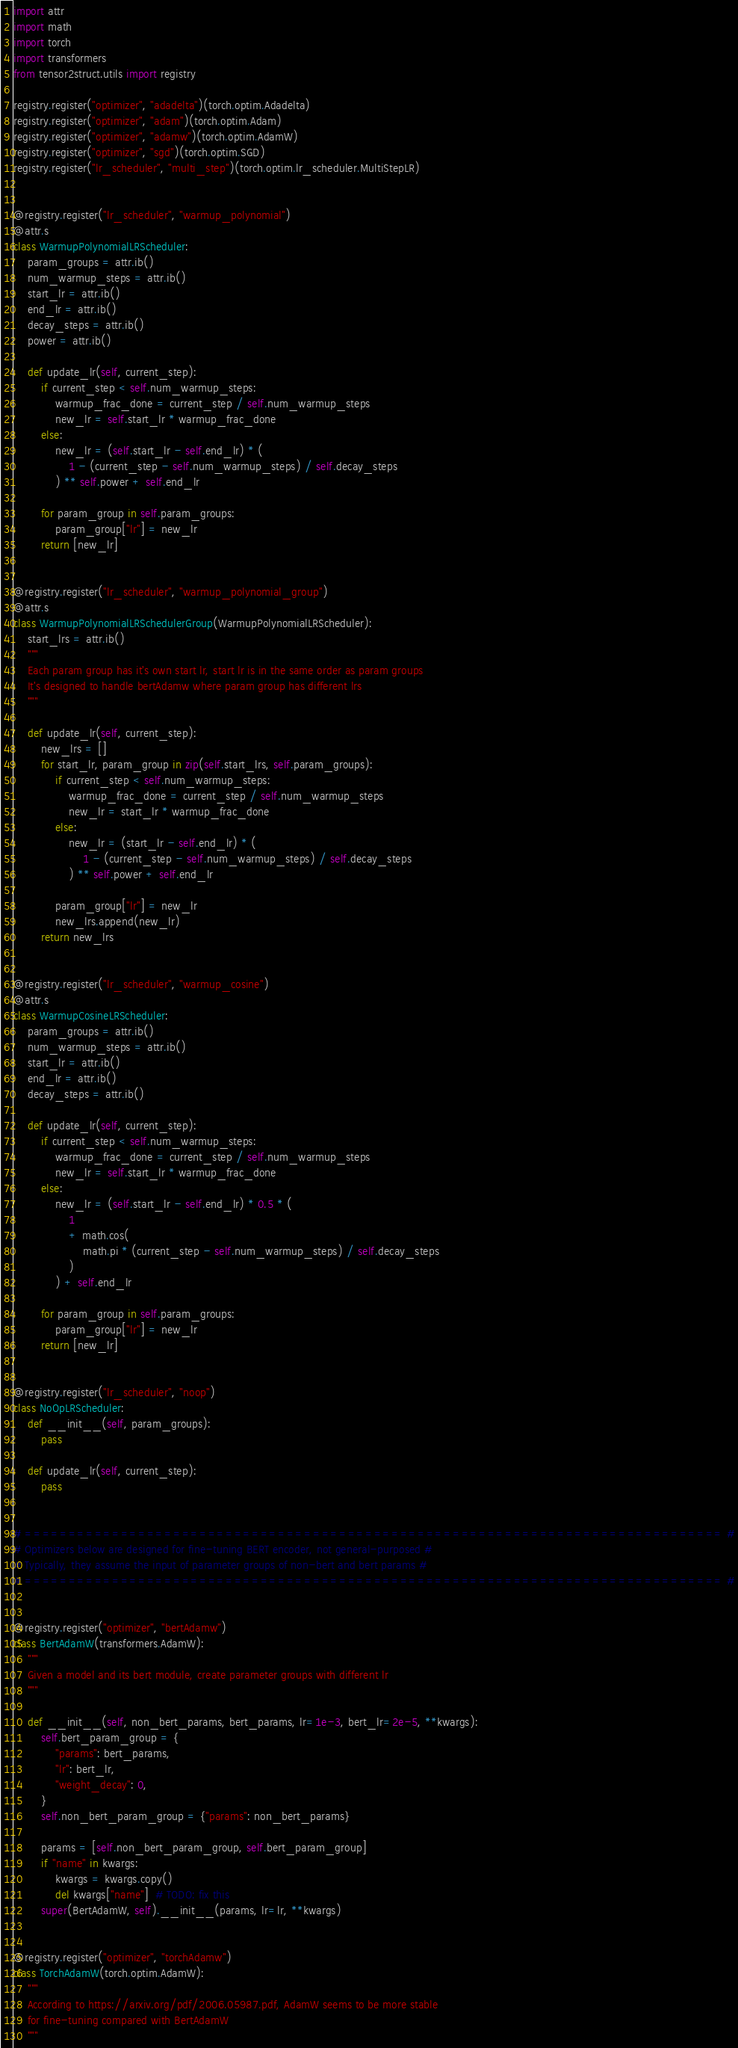<code> <loc_0><loc_0><loc_500><loc_500><_Python_>import attr
import math
import torch
import transformers
from tensor2struct.utils import registry

registry.register("optimizer", "adadelta")(torch.optim.Adadelta)
registry.register("optimizer", "adam")(torch.optim.Adam)
registry.register("optimizer", "adamw")(torch.optim.AdamW)
registry.register("optimizer", "sgd")(torch.optim.SGD)
registry.register("lr_scheduler", "multi_step")(torch.optim.lr_scheduler.MultiStepLR)


@registry.register("lr_scheduler", "warmup_polynomial")
@attr.s
class WarmupPolynomialLRScheduler:
    param_groups = attr.ib()
    num_warmup_steps = attr.ib()
    start_lr = attr.ib()
    end_lr = attr.ib()
    decay_steps = attr.ib()
    power = attr.ib()

    def update_lr(self, current_step):
        if current_step < self.num_warmup_steps:
            warmup_frac_done = current_step / self.num_warmup_steps
            new_lr = self.start_lr * warmup_frac_done
        else:
            new_lr = (self.start_lr - self.end_lr) * (
                1 - (current_step - self.num_warmup_steps) / self.decay_steps
            ) ** self.power + self.end_lr

        for param_group in self.param_groups:
            param_group["lr"] = new_lr
        return [new_lr]


@registry.register("lr_scheduler", "warmup_polynomial_group")
@attr.s
class WarmupPolynomialLRSchedulerGroup(WarmupPolynomialLRScheduler):
    start_lrs = attr.ib()
    """
    Each param group has it's own start lr, start lr is in the same order as param groups
    It's designed to handle bertAdamw where param group has different lrs
    """

    def update_lr(self, current_step):
        new_lrs = []
        for start_lr, param_group in zip(self.start_lrs, self.param_groups):
            if current_step < self.num_warmup_steps:
                warmup_frac_done = current_step / self.num_warmup_steps
                new_lr = start_lr * warmup_frac_done
            else:
                new_lr = (start_lr - self.end_lr) * (
                    1 - (current_step - self.num_warmup_steps) / self.decay_steps
                ) ** self.power + self.end_lr

            param_group["lr"] = new_lr
            new_lrs.append(new_lr)
        return new_lrs


@registry.register("lr_scheduler", "warmup_cosine")
@attr.s
class WarmupCosineLRScheduler:
    param_groups = attr.ib()
    num_warmup_steps = attr.ib()
    start_lr = attr.ib()
    end_lr = attr.ib()
    decay_steps = attr.ib()

    def update_lr(self, current_step):
        if current_step < self.num_warmup_steps:
            warmup_frac_done = current_step / self.num_warmup_steps
            new_lr = self.start_lr * warmup_frac_done
        else:
            new_lr = (self.start_lr - self.end_lr) * 0.5 * (
                1
                + math.cos(
                    math.pi * (current_step - self.num_warmup_steps) / self.decay_steps
                )
            ) + self.end_lr

        for param_group in self.param_groups:
            param_group["lr"] = new_lr
        return [new_lr]


@registry.register("lr_scheduler", "noop")
class NoOpLRScheduler:
    def __init__(self, param_groups):
        pass

    def update_lr(self, current_step):
        pass


# ================================================================================ #
# Optimizers below are designed for fine-tuning BERT encoder, not general-purposed #
# Typically, they assume the input of parameter groups of non-bert and bert params #
# ================================================================================ #


@registry.register("optimizer", "bertAdamw")
class BertAdamW(transformers.AdamW):
    """
    Given a model and its bert module, create parameter groups with different lr
    """

    def __init__(self, non_bert_params, bert_params, lr=1e-3, bert_lr=2e-5, **kwargs):
        self.bert_param_group = {
            "params": bert_params,
            "lr": bert_lr,
            "weight_decay": 0,
        }
        self.non_bert_param_group = {"params": non_bert_params}

        params = [self.non_bert_param_group, self.bert_param_group]
        if "name" in kwargs:
            kwargs = kwargs.copy()
            del kwargs["name"]  # TODO: fix this
        super(BertAdamW, self).__init__(params, lr=lr, **kwargs)


@registry.register("optimizer", "torchAdamw")
class TorchAdamW(torch.optim.AdamW):
    """
    According to https://arxiv.org/pdf/2006.05987.pdf, AdamW seems to be more stable 
    for fine-tuning compared with BertAdamW
    """
</code> 